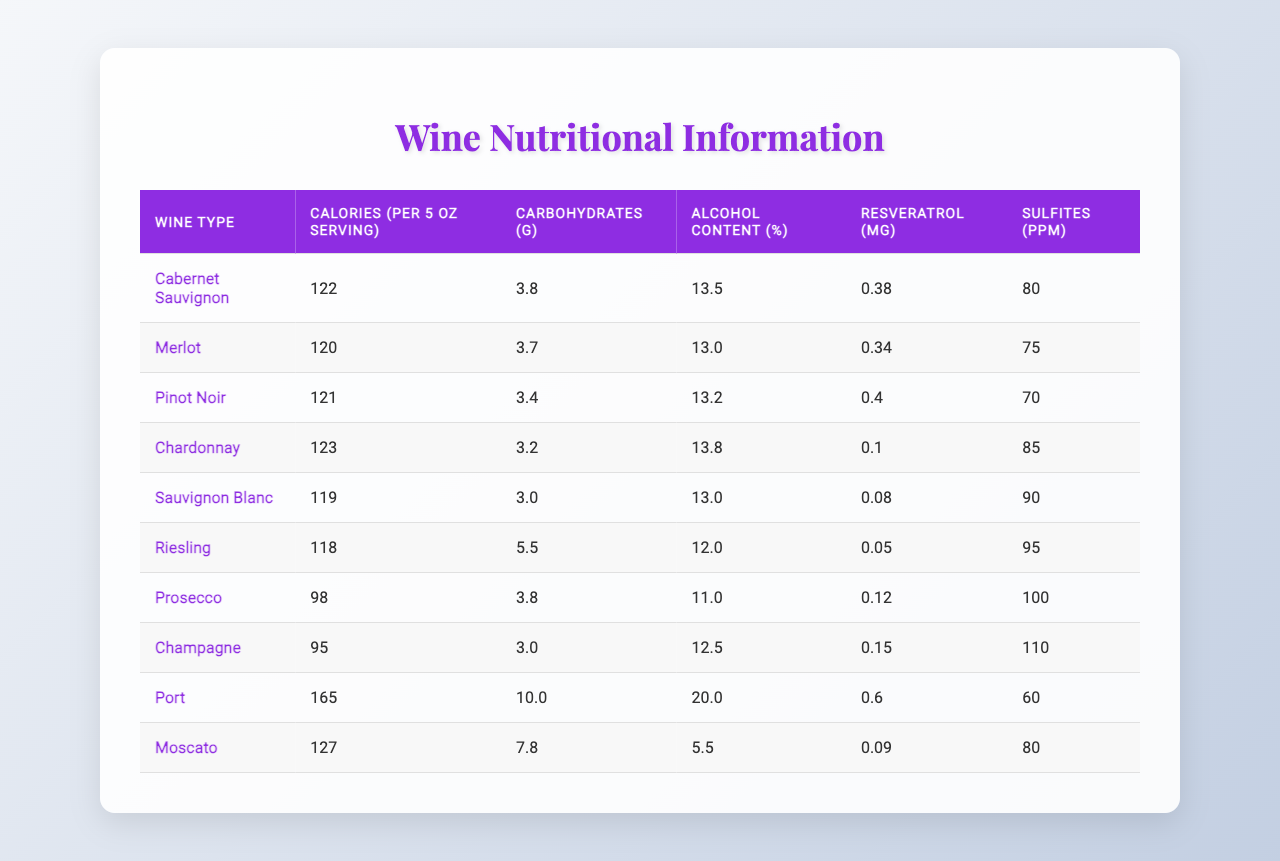What is the calorie content of a 5 oz serving of Merlot? The table lists "Merlot" under the "Wine Type" column, where the calorie content is indicated as 120 calories per 5 oz serving.
Answer: 120 calories Which wine type has the highest alcohol content? To determine the highest alcohol content from the table, we compare the "Alcohol Content (%)" values listed for each type of wine. The highest value is 20.0%, which corresponds to "Port."
Answer: Port What is the average calorie content of white wines listed in the table? The white wines in the table are "Chardonnay," "Sauvignon Blanc," "Riesling," "Prosecco," and "Champagne." Their calorie contents are 123, 119, 118, 98, and 95 respectively. Summing these values gives 123 + 119 + 118 + 98 + 95 = 553. Dividing by the number of wines (5) gives an average of 553 / 5 = 110.6, rounded down to 110.
Answer: 110.6 Is the resveratrol content in Pinot Noir greater than that in Sauvignon Blanc? The table shows that "Pinot Noir" has 0.40 mg of resveratrol while "Sauvignon Blanc" has only 0.08 mg. Since 0.40 is greater than 0.08, the statement is true.
Answer: Yes What is the difference in calories between the highest and lowest calorie wine? The highest calorie wine is "Port" with 165 calories and the lowest is "Champagne" with 95 calories. The difference is calculated as 165 - 95 = 70 calories.
Answer: 70 calories Which wine type has the least carbohydrates per serving? By reviewing the "Carbohydrates (g)" column, the wine type "Sauvignon Blanc" has the least carbohydrates listed at 3.0 grams.
Answer: Sauvignon Blanc How does the alcohol content of Riesling compare to that of Prosecco? Riesling has an alcohol content of 12.0%, while Prosecco has an alcohol content of 11.0%. Since 12.0% is greater than 11.0%, Riesling has a higher alcohol content than Prosecco.
Answer: Yes What is the total amount of sulfites in the red wines listed? The red wines are "Cabernet Sauvignon," "Merlot," "Pinot Noir," and "Port," with sulfite levels of 80, 75, 70, and 60 ppm respectively. Adding these gives 80 + 75 + 70 + 60 = 285 ppm.
Answer: 285 ppm Which wine has the highest resveratrol content? Checking the "Resveratrol (mg)" column for each wine, "Port" has the highest content at 0.60 mg.
Answer: Port If you combine the calories from Chardonnay and Moscato, what is the total? The calories for "Chardonnay" are 123 and for "Moscato," they are 127. Adding these gives 123 + 127 = 250 calories.
Answer: 250 calories 